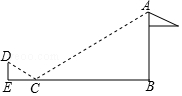What practical applications can we draw from this mirror method used to measure the flagpole's height? The mirror method for measuring the flagpole's height is an ingenious illustration of indirect measurement techniques. This approach is particularly useful in situations where direct measurement is either impossible or impractical due to the object's size, inaccessibility, or danger involved. Practical applications of this method extend to fields like surveying, architecture, forestry, and even astronomy, where similar principles are applied to calculate distances to celestial bodies. It's a testament to how creative thinking and an understanding of basic physical and mathematical principles can solve real-world problems efficiently and safely. 